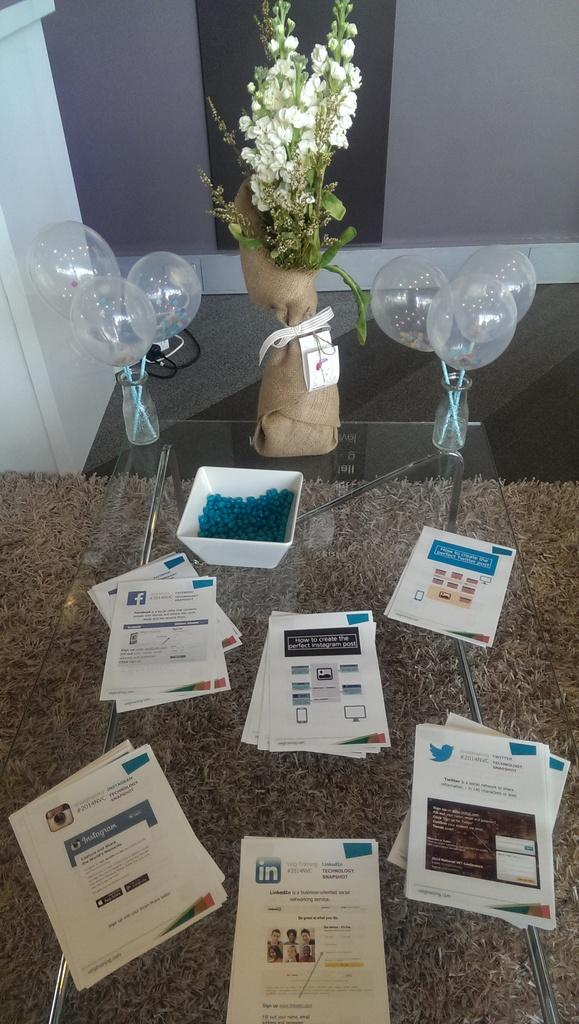What is the main piece of furniture in the image? There is a table in the image. What is placed on the table? There are papers and a bowl with objects on the table. What type of decoration is present in the image? There are balloons in the image. What is the surface on which the table is placed? There is a mat in the image. What can be seen in the background of the image? There is a wall visible in the image. What type of test is being conducted in the image? There is no indication of a test being conducted in the image. Can you see a bear in the image? There is no bear present in the image. 